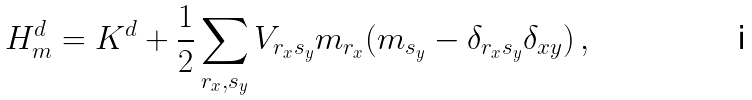Convert formula to latex. <formula><loc_0><loc_0><loc_500><loc_500>H _ { m } ^ { d } = K ^ { d } + \frac { 1 } { 2 } \sum _ { r _ { x } , s _ { y } } V _ { r _ { x } s _ { y } } m _ { r _ { x } } ( m _ { s _ { y } } - \delta _ { r _ { x } s _ { y } } \delta _ { x y } ) \, ,</formula> 